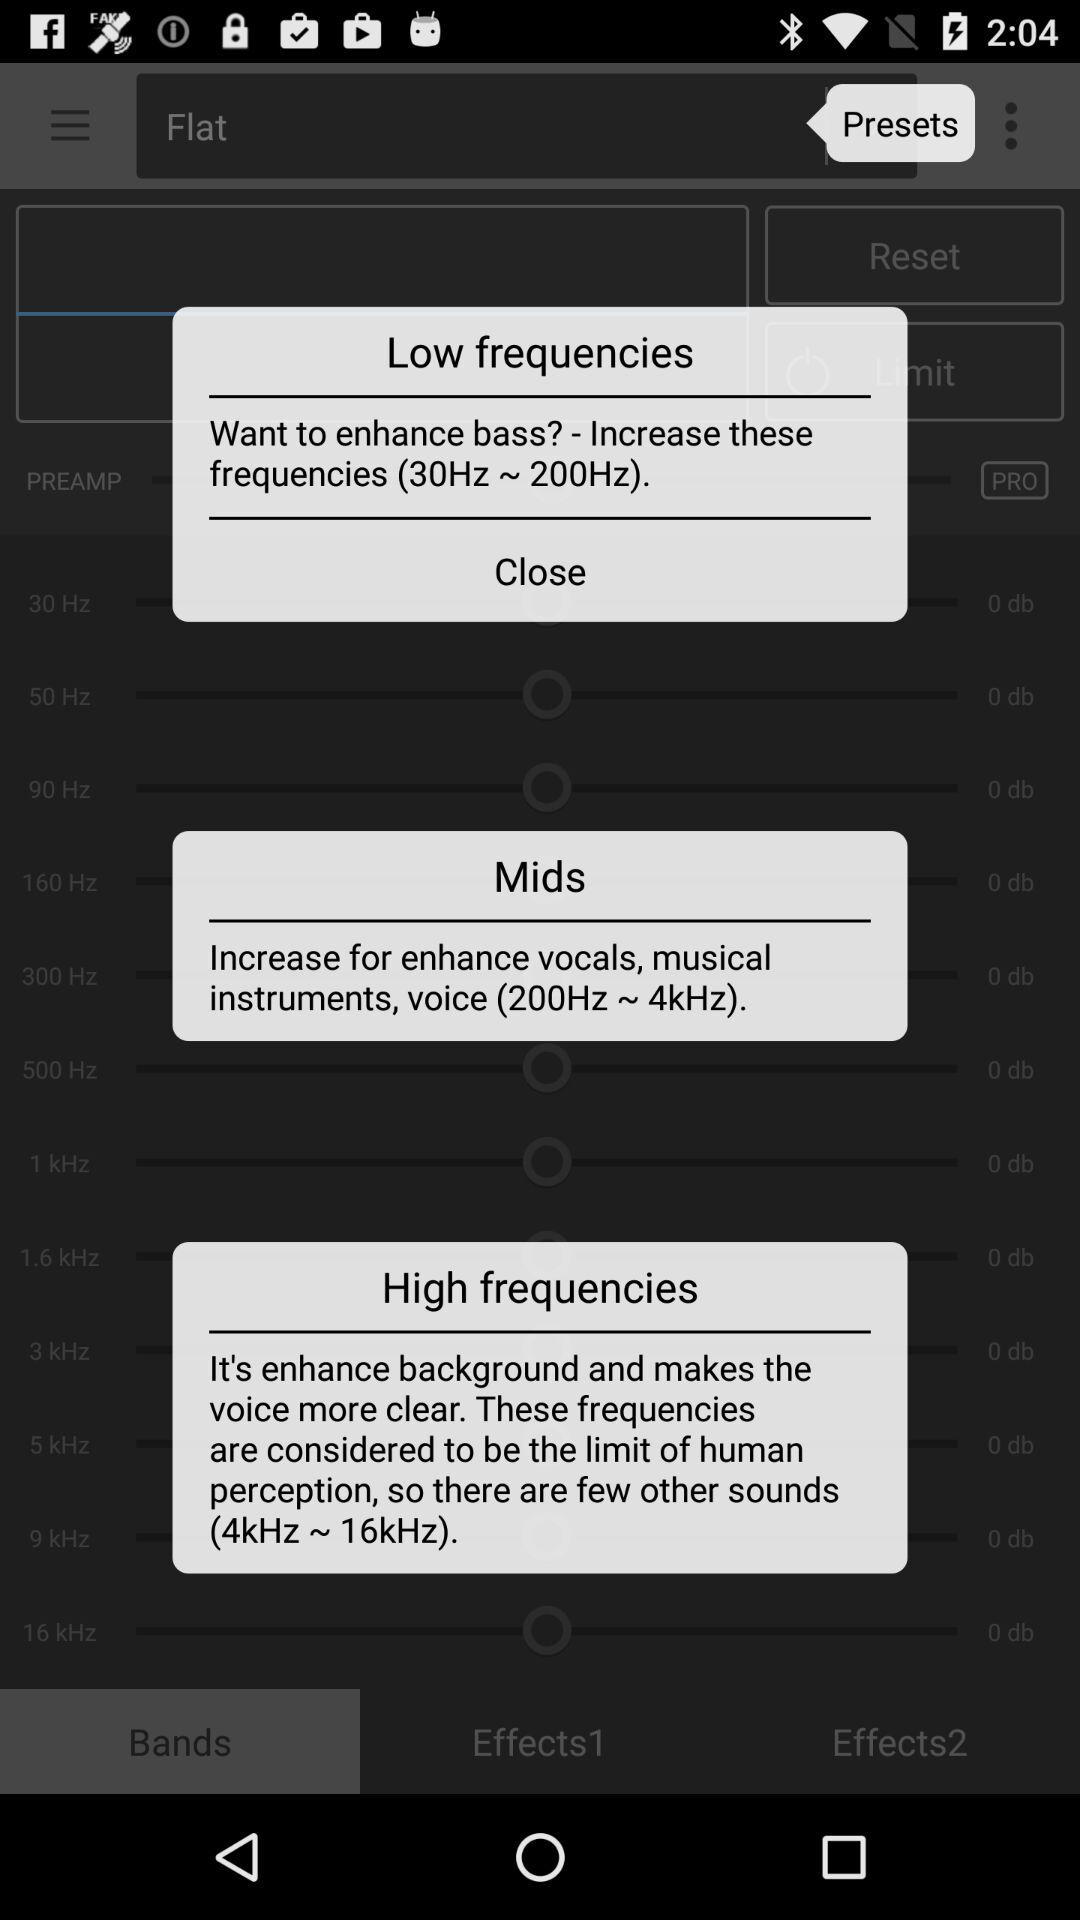How many frequencies are mentioned in the description?
Answer the question using a single word or phrase. 3 